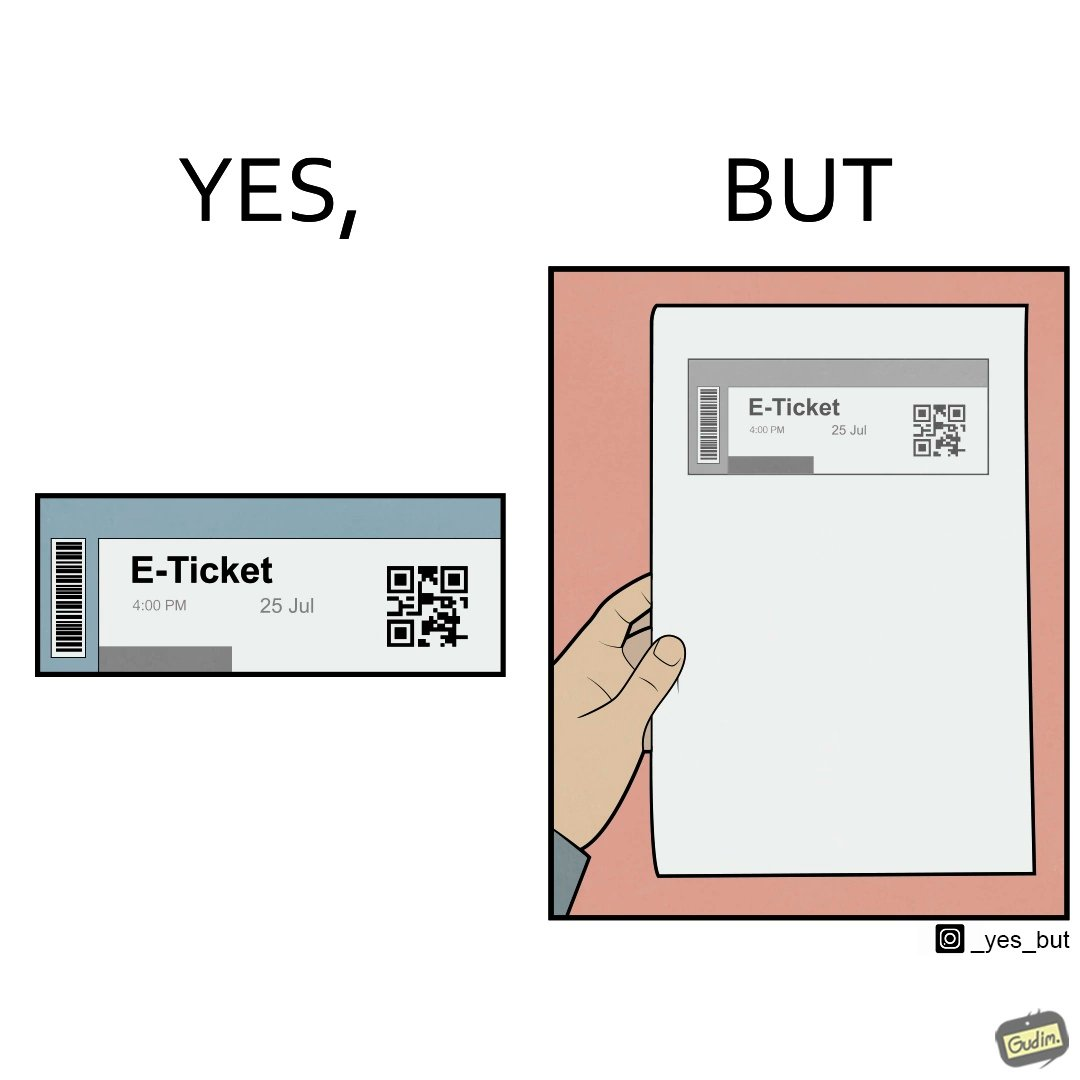What is the satirical meaning behind this image? The images are ironic since even though e-tickets are provided to save resources like paper, people choose to print out e-tickets on large sheets of paper which leads to more wastage 